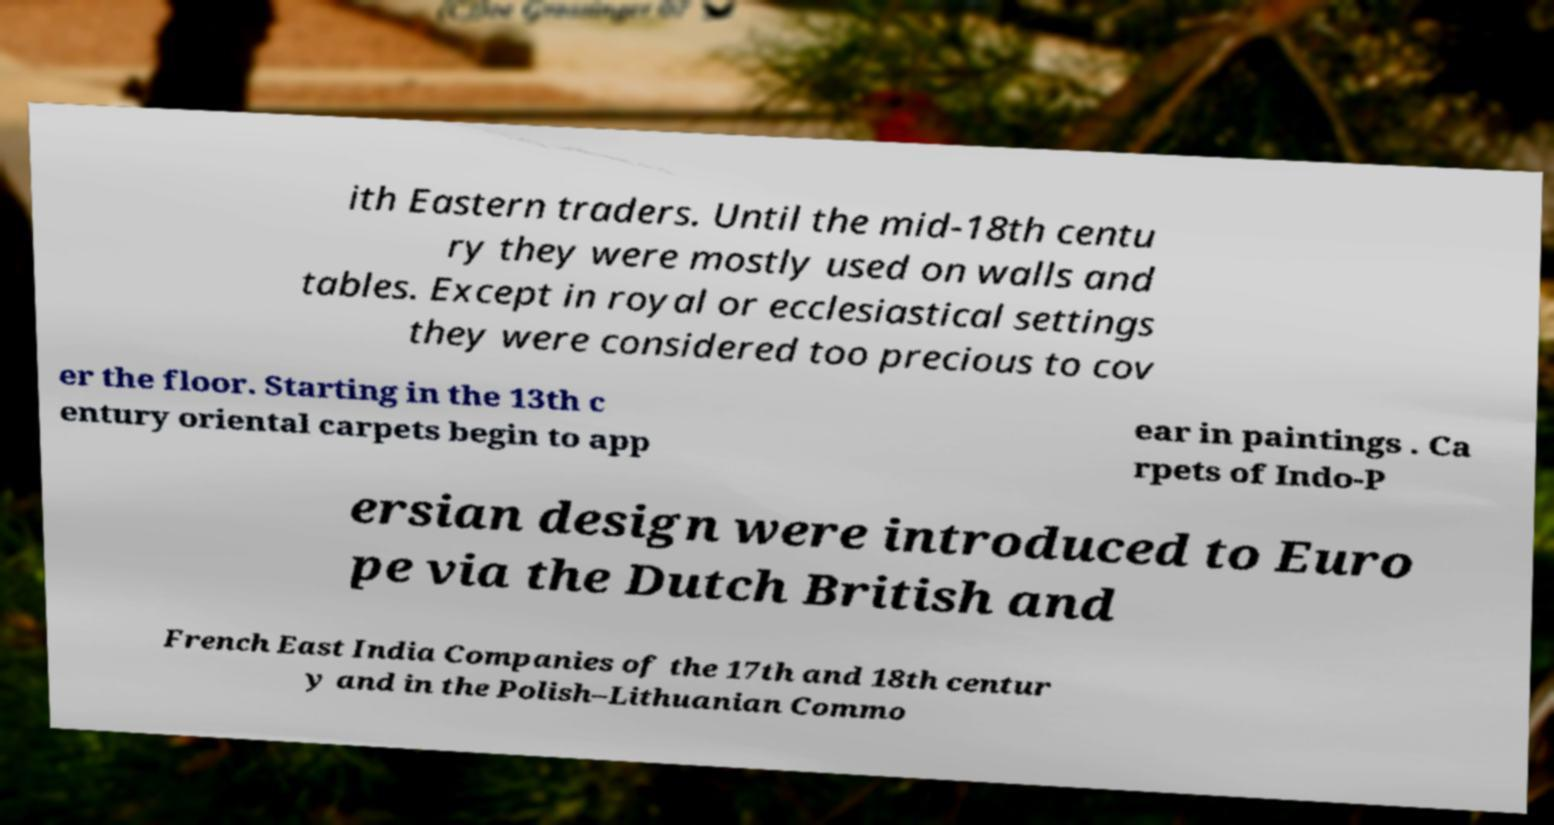What messages or text are displayed in this image? I need them in a readable, typed format. ith Eastern traders. Until the mid-18th centu ry they were mostly used on walls and tables. Except in royal or ecclesiastical settings they were considered too precious to cov er the floor. Starting in the 13th c entury oriental carpets begin to app ear in paintings . Ca rpets of Indo-P ersian design were introduced to Euro pe via the Dutch British and French East India Companies of the 17th and 18th centur y and in the Polish–Lithuanian Commo 